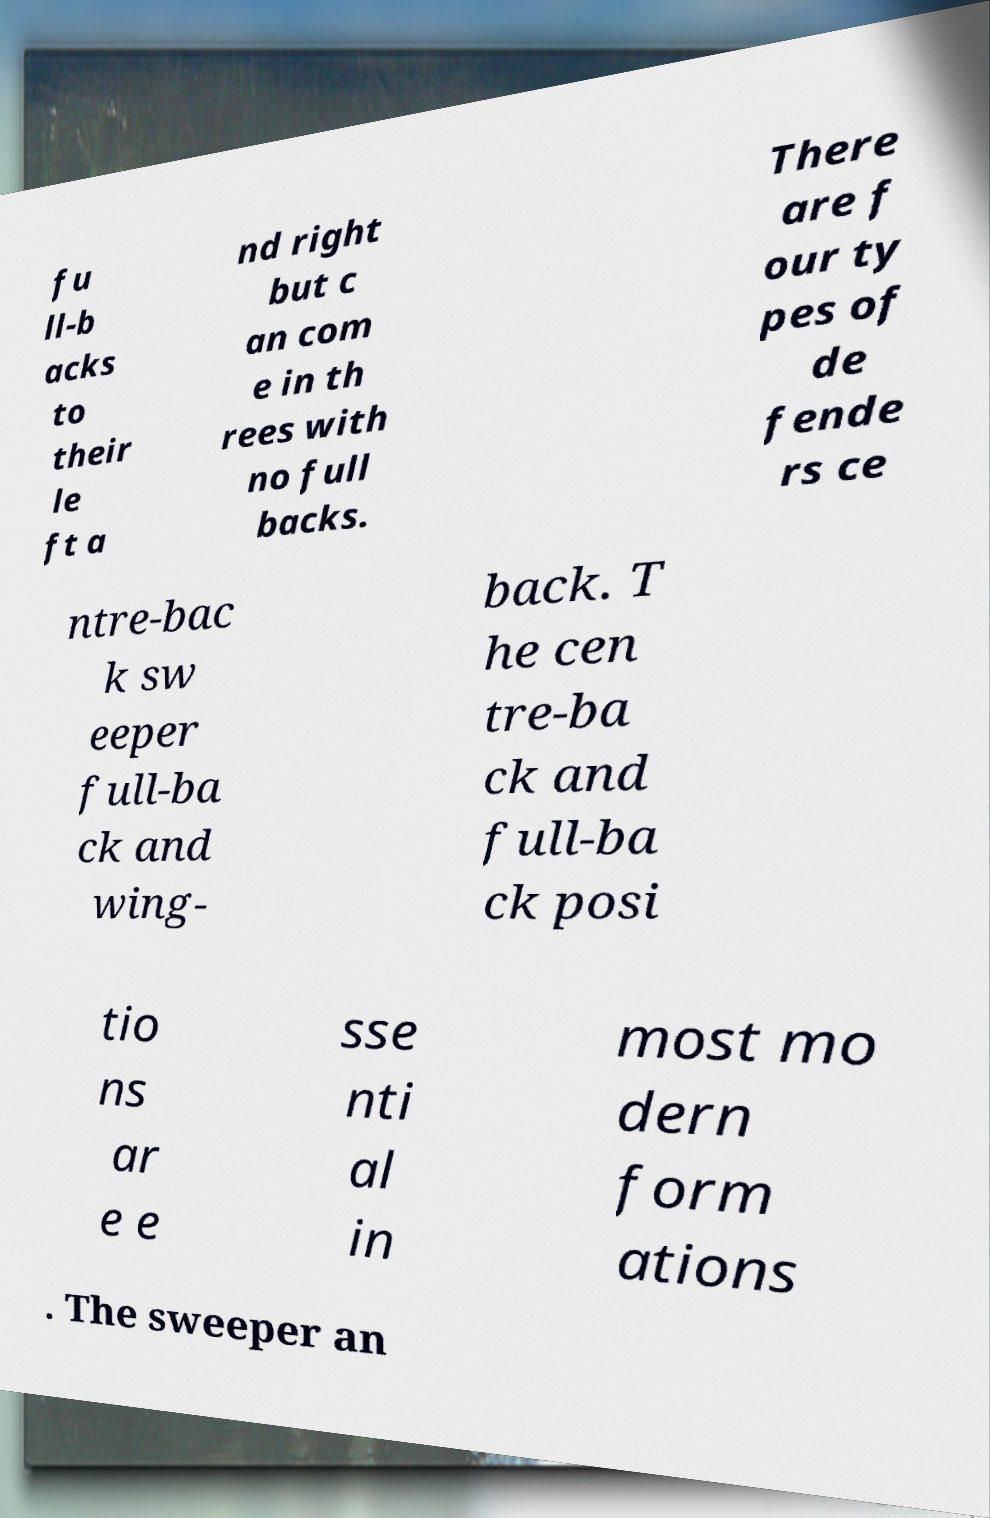Can you accurately transcribe the text from the provided image for me? fu ll-b acks to their le ft a nd right but c an com e in th rees with no full backs. There are f our ty pes of de fende rs ce ntre-bac k sw eeper full-ba ck and wing- back. T he cen tre-ba ck and full-ba ck posi tio ns ar e e sse nti al in most mo dern form ations . The sweeper an 